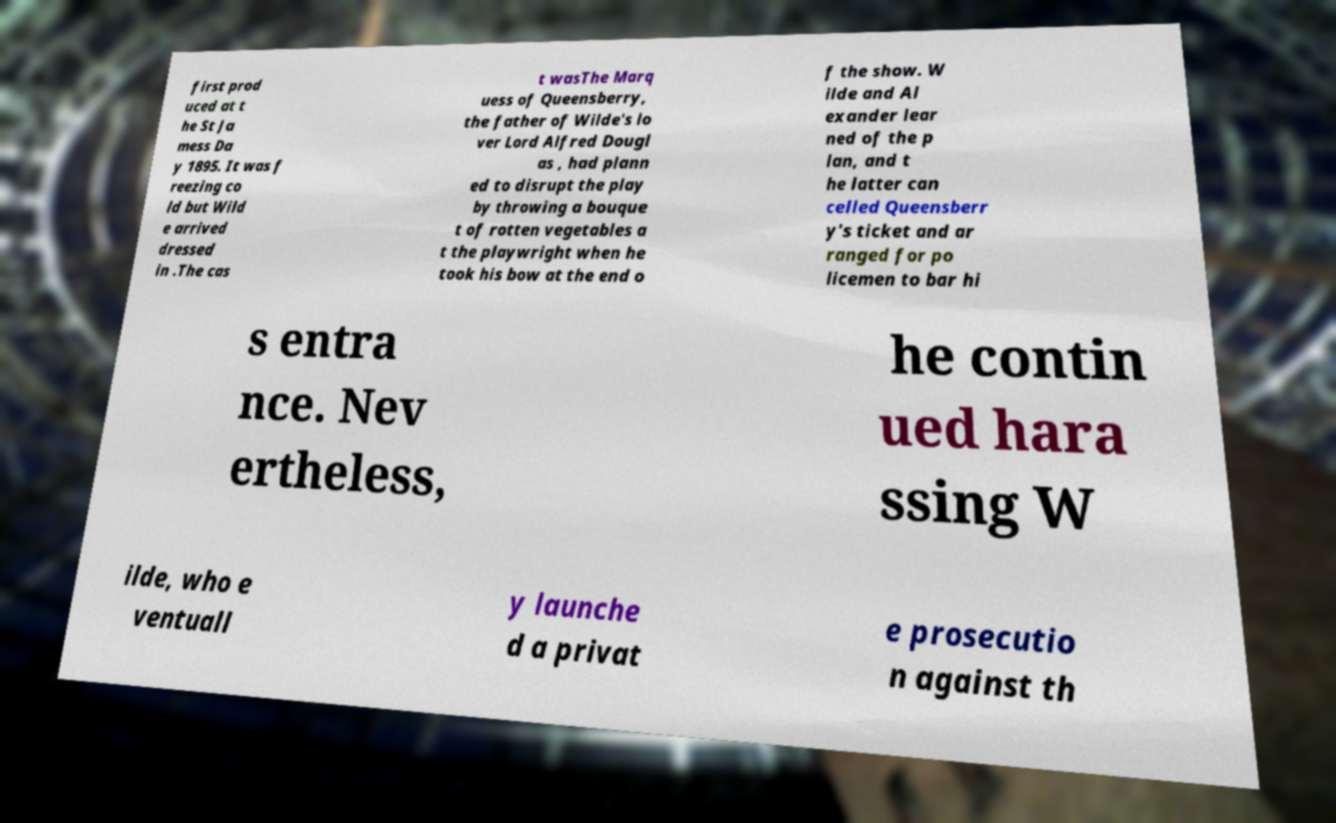Could you extract and type out the text from this image? first prod uced at t he St Ja mess Da y 1895. It was f reezing co ld but Wild e arrived dressed in .The cas t wasThe Marq uess of Queensberry, the father of Wilde's lo ver Lord Alfred Dougl as , had plann ed to disrupt the play by throwing a bouque t of rotten vegetables a t the playwright when he took his bow at the end o f the show. W ilde and Al exander lear ned of the p lan, and t he latter can celled Queensberr y's ticket and ar ranged for po licemen to bar hi s entra nce. Nev ertheless, he contin ued hara ssing W ilde, who e ventuall y launche d a privat e prosecutio n against th 